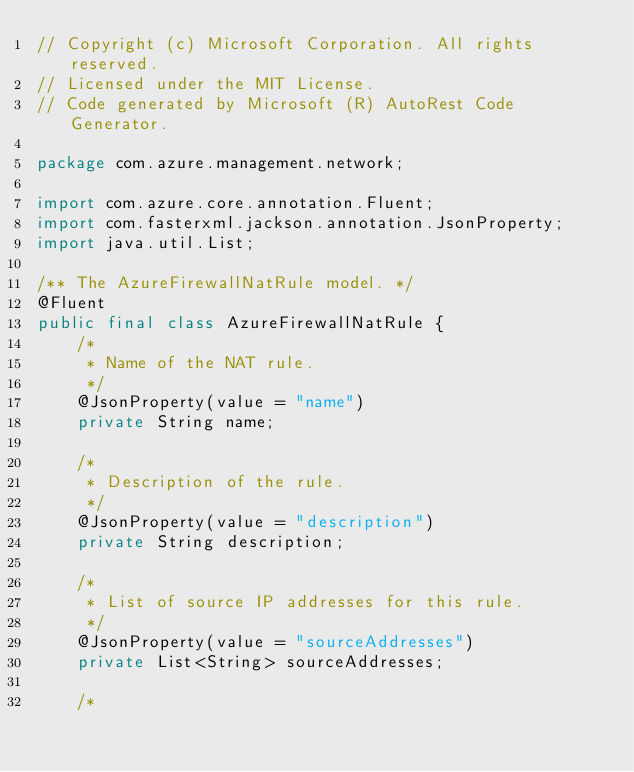Convert code to text. <code><loc_0><loc_0><loc_500><loc_500><_Java_>// Copyright (c) Microsoft Corporation. All rights reserved.
// Licensed under the MIT License.
// Code generated by Microsoft (R) AutoRest Code Generator.

package com.azure.management.network;

import com.azure.core.annotation.Fluent;
import com.fasterxml.jackson.annotation.JsonProperty;
import java.util.List;

/** The AzureFirewallNatRule model. */
@Fluent
public final class AzureFirewallNatRule {
    /*
     * Name of the NAT rule.
     */
    @JsonProperty(value = "name")
    private String name;

    /*
     * Description of the rule.
     */
    @JsonProperty(value = "description")
    private String description;

    /*
     * List of source IP addresses for this rule.
     */
    @JsonProperty(value = "sourceAddresses")
    private List<String> sourceAddresses;

    /*</code> 